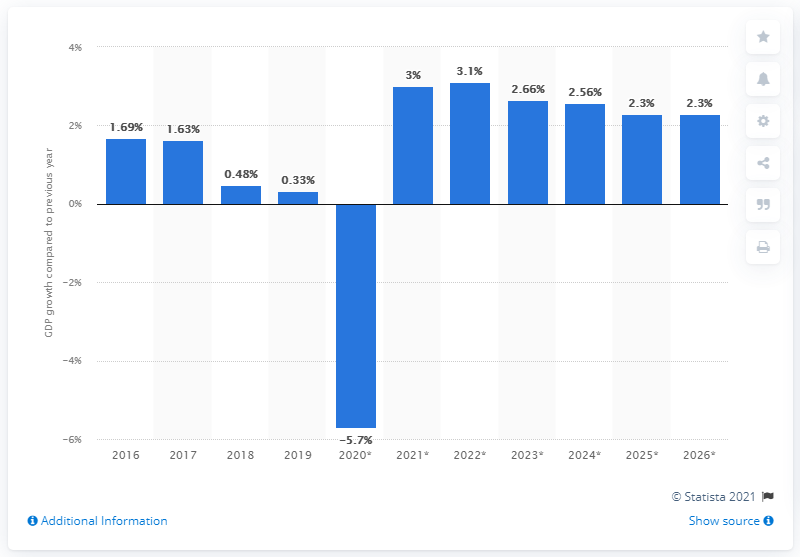Give some essential details in this illustration. Uruguay's gross domestic product grew by 0.33% in 2019. 